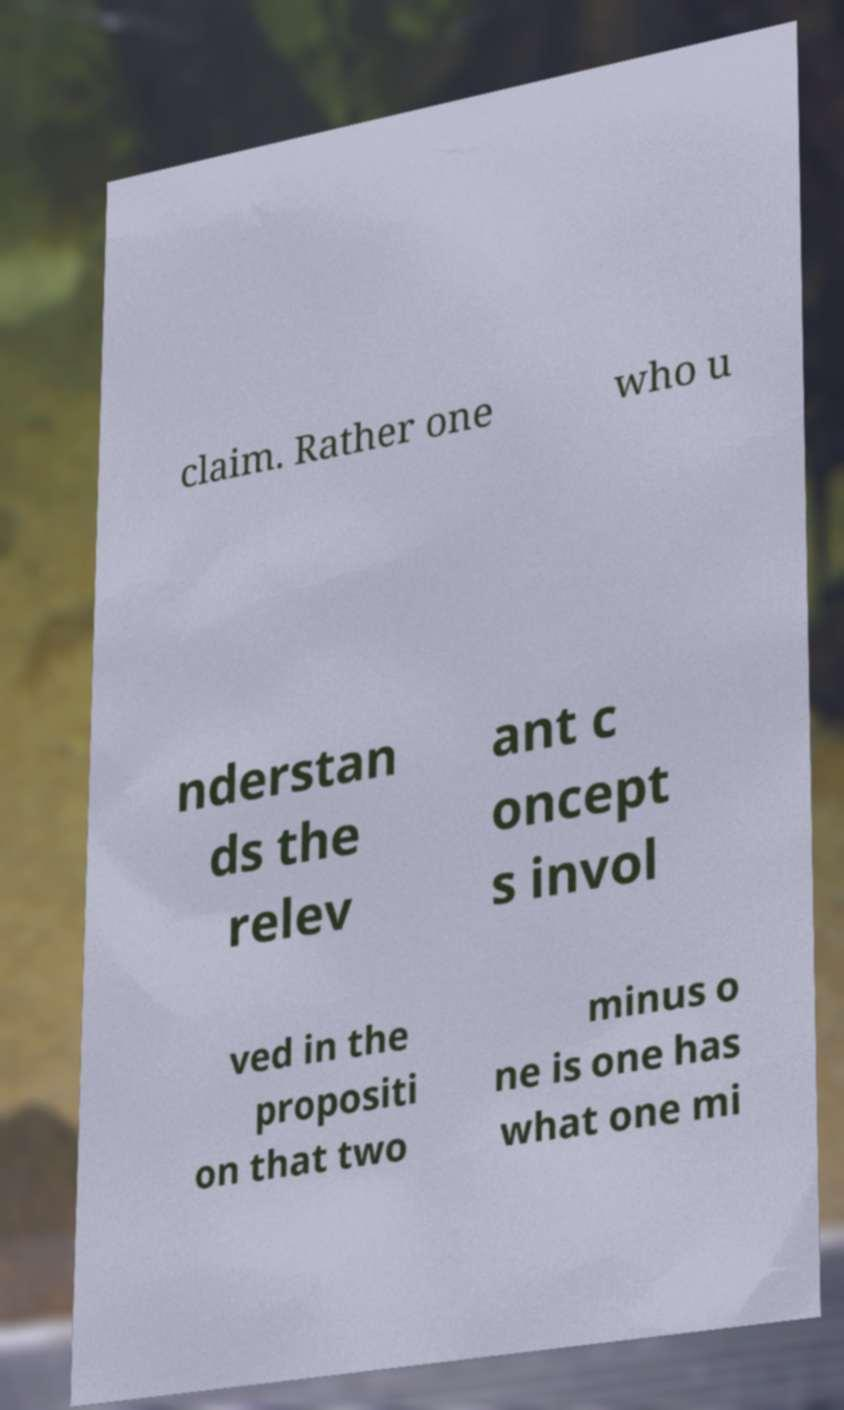Can you accurately transcribe the text from the provided image for me? claim. Rather one who u nderstan ds the relev ant c oncept s invol ved in the propositi on that two minus o ne is one has what one mi 